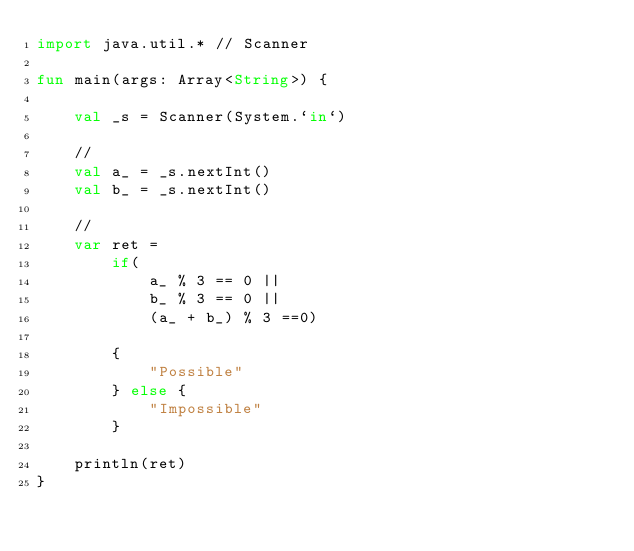<code> <loc_0><loc_0><loc_500><loc_500><_Kotlin_>import java.util.* // Scanner

fun main(args: Array<String>) {

    val _s = Scanner(System.`in`)

    //
    val a_ = _s.nextInt()
    val b_ = _s.nextInt()

    //
    var ret = 
        if(
            a_ % 3 == 0 ||       
            b_ % 3 == 0 || 
            (a_ + b_) % 3 ==0) 
            
        {
            "Possible"
        } else {
            "Impossible"
        }

    println(ret)
}</code> 